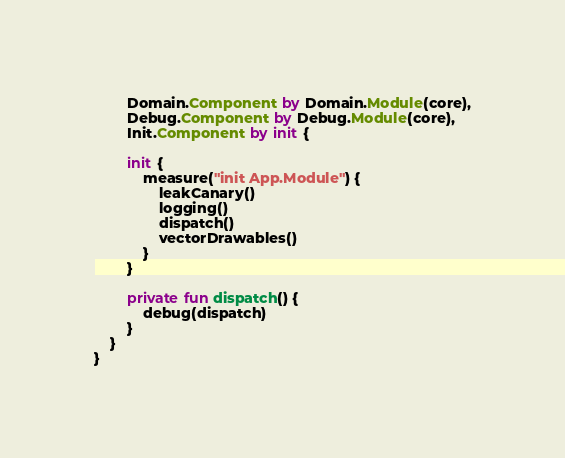Convert code to text. <code><loc_0><loc_0><loc_500><loc_500><_Kotlin_>        Domain.Component by Domain.Module(core),
        Debug.Component by Debug.Module(core),
        Init.Component by init {

        init {
            measure("init App.Module") {
                leakCanary()
                logging()
                dispatch()
                vectorDrawables()
            }
        }

        private fun dispatch() {
            debug(dispatch)
        }
    }
}
</code> 